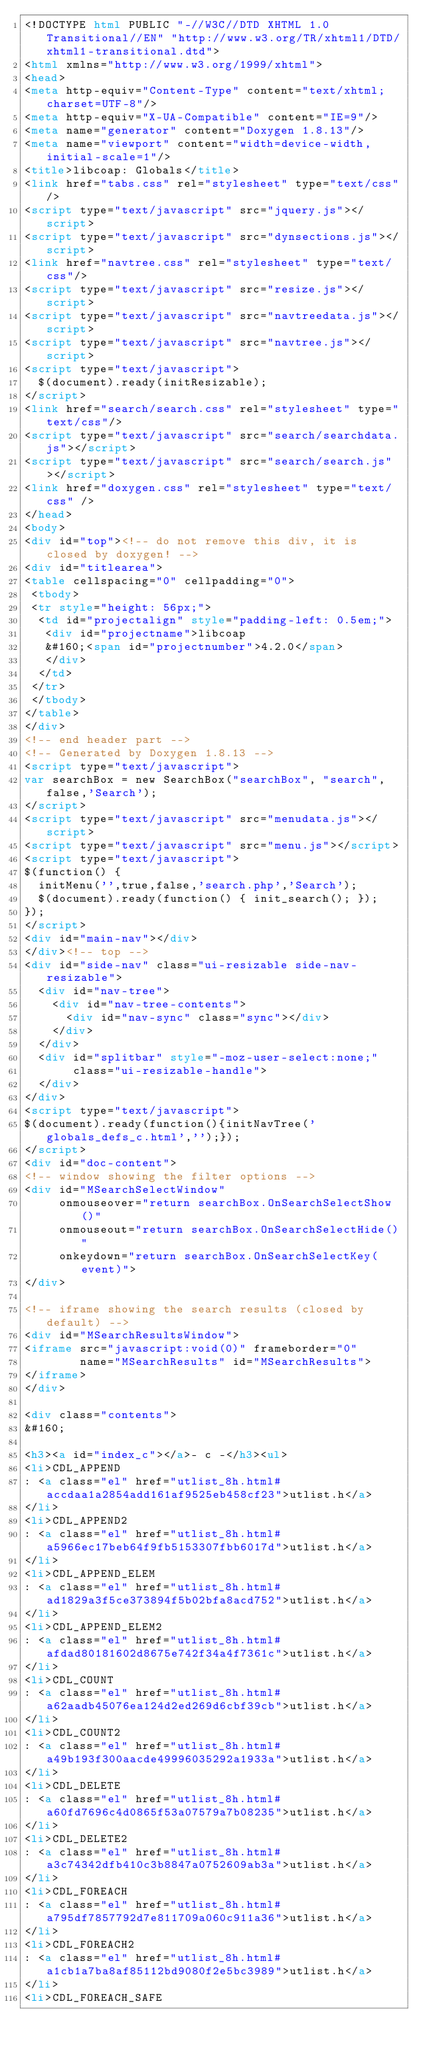Convert code to text. <code><loc_0><loc_0><loc_500><loc_500><_HTML_><!DOCTYPE html PUBLIC "-//W3C//DTD XHTML 1.0 Transitional//EN" "http://www.w3.org/TR/xhtml1/DTD/xhtml1-transitional.dtd">
<html xmlns="http://www.w3.org/1999/xhtml">
<head>
<meta http-equiv="Content-Type" content="text/xhtml;charset=UTF-8"/>
<meta http-equiv="X-UA-Compatible" content="IE=9"/>
<meta name="generator" content="Doxygen 1.8.13"/>
<meta name="viewport" content="width=device-width, initial-scale=1"/>
<title>libcoap: Globals</title>
<link href="tabs.css" rel="stylesheet" type="text/css"/>
<script type="text/javascript" src="jquery.js"></script>
<script type="text/javascript" src="dynsections.js"></script>
<link href="navtree.css" rel="stylesheet" type="text/css"/>
<script type="text/javascript" src="resize.js"></script>
<script type="text/javascript" src="navtreedata.js"></script>
<script type="text/javascript" src="navtree.js"></script>
<script type="text/javascript">
  $(document).ready(initResizable);
</script>
<link href="search/search.css" rel="stylesheet" type="text/css"/>
<script type="text/javascript" src="search/searchdata.js"></script>
<script type="text/javascript" src="search/search.js"></script>
<link href="doxygen.css" rel="stylesheet" type="text/css" />
</head>
<body>
<div id="top"><!-- do not remove this div, it is closed by doxygen! -->
<div id="titlearea">
<table cellspacing="0" cellpadding="0">
 <tbody>
 <tr style="height: 56px;">
  <td id="projectalign" style="padding-left: 0.5em;">
   <div id="projectname">libcoap
   &#160;<span id="projectnumber">4.2.0</span>
   </div>
  </td>
 </tr>
 </tbody>
</table>
</div>
<!-- end header part -->
<!-- Generated by Doxygen 1.8.13 -->
<script type="text/javascript">
var searchBox = new SearchBox("searchBox", "search",false,'Search');
</script>
<script type="text/javascript" src="menudata.js"></script>
<script type="text/javascript" src="menu.js"></script>
<script type="text/javascript">
$(function() {
  initMenu('',true,false,'search.php','Search');
  $(document).ready(function() { init_search(); });
});
</script>
<div id="main-nav"></div>
</div><!-- top -->
<div id="side-nav" class="ui-resizable side-nav-resizable">
  <div id="nav-tree">
    <div id="nav-tree-contents">
      <div id="nav-sync" class="sync"></div>
    </div>
  </div>
  <div id="splitbar" style="-moz-user-select:none;" 
       class="ui-resizable-handle">
  </div>
</div>
<script type="text/javascript">
$(document).ready(function(){initNavTree('globals_defs_c.html','');});
</script>
<div id="doc-content">
<!-- window showing the filter options -->
<div id="MSearchSelectWindow"
     onmouseover="return searchBox.OnSearchSelectShow()"
     onmouseout="return searchBox.OnSearchSelectHide()"
     onkeydown="return searchBox.OnSearchSelectKey(event)">
</div>

<!-- iframe showing the search results (closed by default) -->
<div id="MSearchResultsWindow">
<iframe src="javascript:void(0)" frameborder="0" 
        name="MSearchResults" id="MSearchResults">
</iframe>
</div>

<div class="contents">
&#160;

<h3><a id="index_c"></a>- c -</h3><ul>
<li>CDL_APPEND
: <a class="el" href="utlist_8h.html#accdaa1a2854add161af9525eb458cf23">utlist.h</a>
</li>
<li>CDL_APPEND2
: <a class="el" href="utlist_8h.html#a5966ec17beb64f9fb5153307fbb6017d">utlist.h</a>
</li>
<li>CDL_APPEND_ELEM
: <a class="el" href="utlist_8h.html#ad1829a3f5ce373894f5b02bfa8acd752">utlist.h</a>
</li>
<li>CDL_APPEND_ELEM2
: <a class="el" href="utlist_8h.html#afdad80181602d8675e742f34a4f7361c">utlist.h</a>
</li>
<li>CDL_COUNT
: <a class="el" href="utlist_8h.html#a62aadb45076ea124d2ed269d6cbf39cb">utlist.h</a>
</li>
<li>CDL_COUNT2
: <a class="el" href="utlist_8h.html#a49b193f300aacde49996035292a1933a">utlist.h</a>
</li>
<li>CDL_DELETE
: <a class="el" href="utlist_8h.html#a60fd7696c4d0865f53a07579a7b08235">utlist.h</a>
</li>
<li>CDL_DELETE2
: <a class="el" href="utlist_8h.html#a3c74342dfb410c3b8847a0752609ab3a">utlist.h</a>
</li>
<li>CDL_FOREACH
: <a class="el" href="utlist_8h.html#a795df7857792d7e811709a060c911a36">utlist.h</a>
</li>
<li>CDL_FOREACH2
: <a class="el" href="utlist_8h.html#a1cb1a7ba8af85112bd9080f2e5bc3989">utlist.h</a>
</li>
<li>CDL_FOREACH_SAFE</code> 